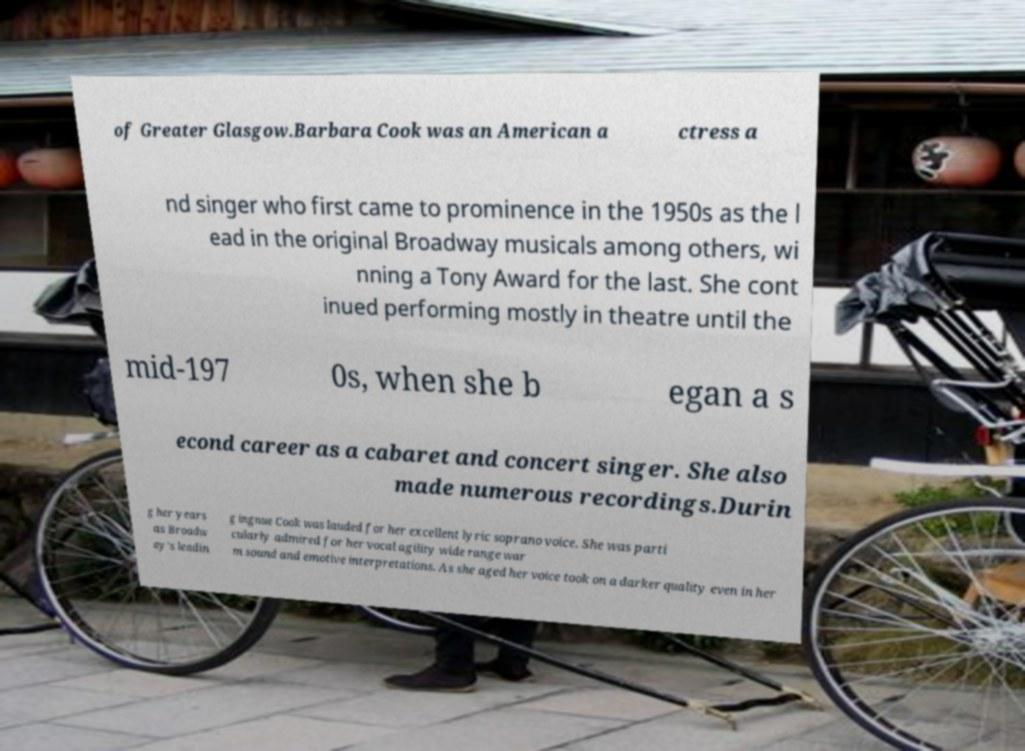What messages or text are displayed in this image? I need them in a readable, typed format. of Greater Glasgow.Barbara Cook was an American a ctress a nd singer who first came to prominence in the 1950s as the l ead in the original Broadway musicals among others, wi nning a Tony Award for the last. She cont inued performing mostly in theatre until the mid-197 0s, when she b egan a s econd career as a cabaret and concert singer. She also made numerous recordings.Durin g her years as Broadw ay’s leadin g ingnue Cook was lauded for her excellent lyric soprano voice. She was parti cularly admired for her vocal agility wide range war m sound and emotive interpretations. As she aged her voice took on a darker quality even in her 